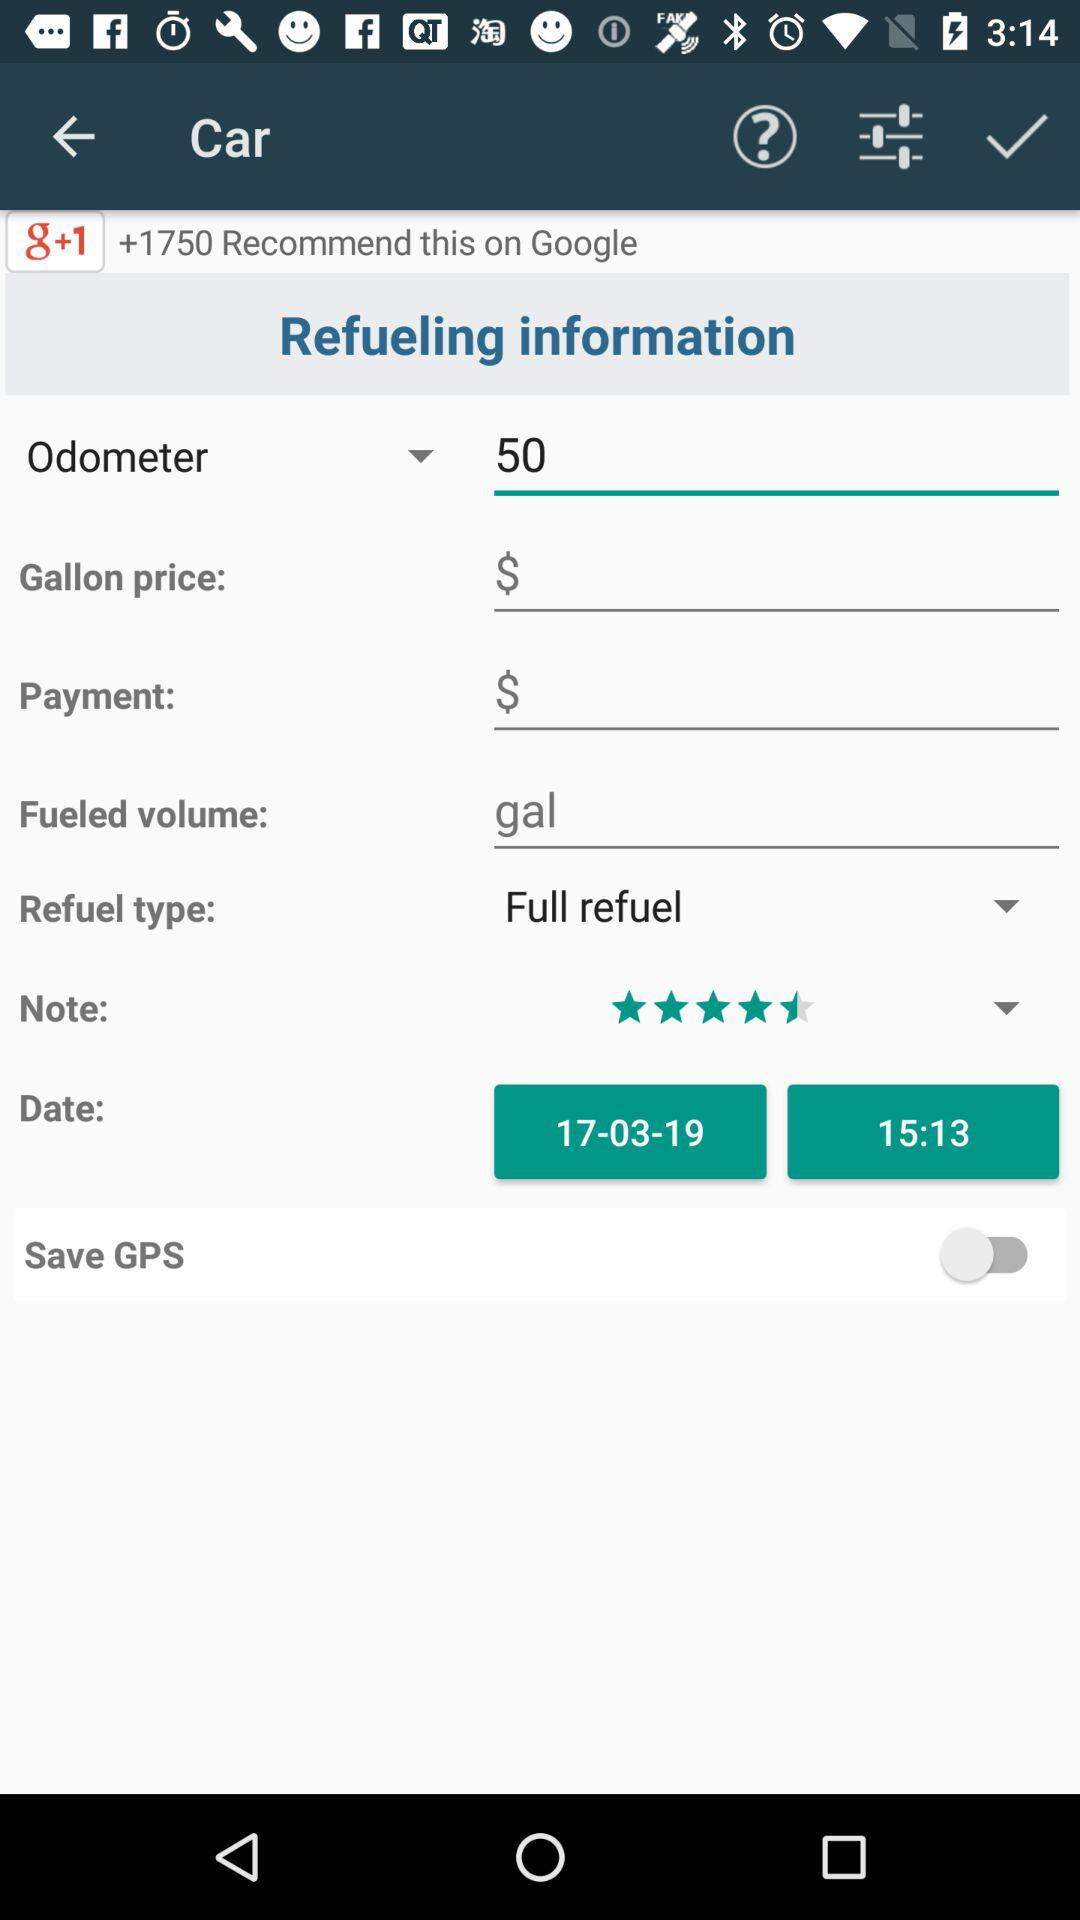What is the status of "Save GPS"? The status of "Save GPS" is "off". 